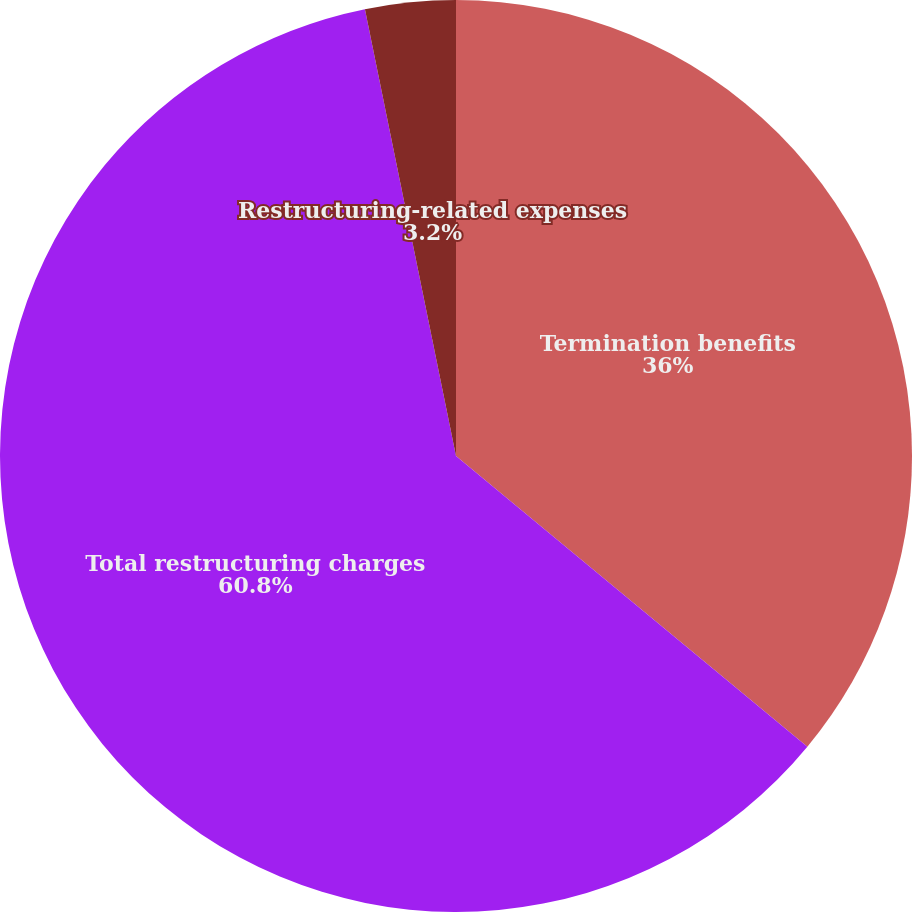Convert chart to OTSL. <chart><loc_0><loc_0><loc_500><loc_500><pie_chart><fcel>Termination benefits<fcel>Total restructuring charges<fcel>Restructuring-related expenses<nl><fcel>36.0%<fcel>60.8%<fcel>3.2%<nl></chart> 